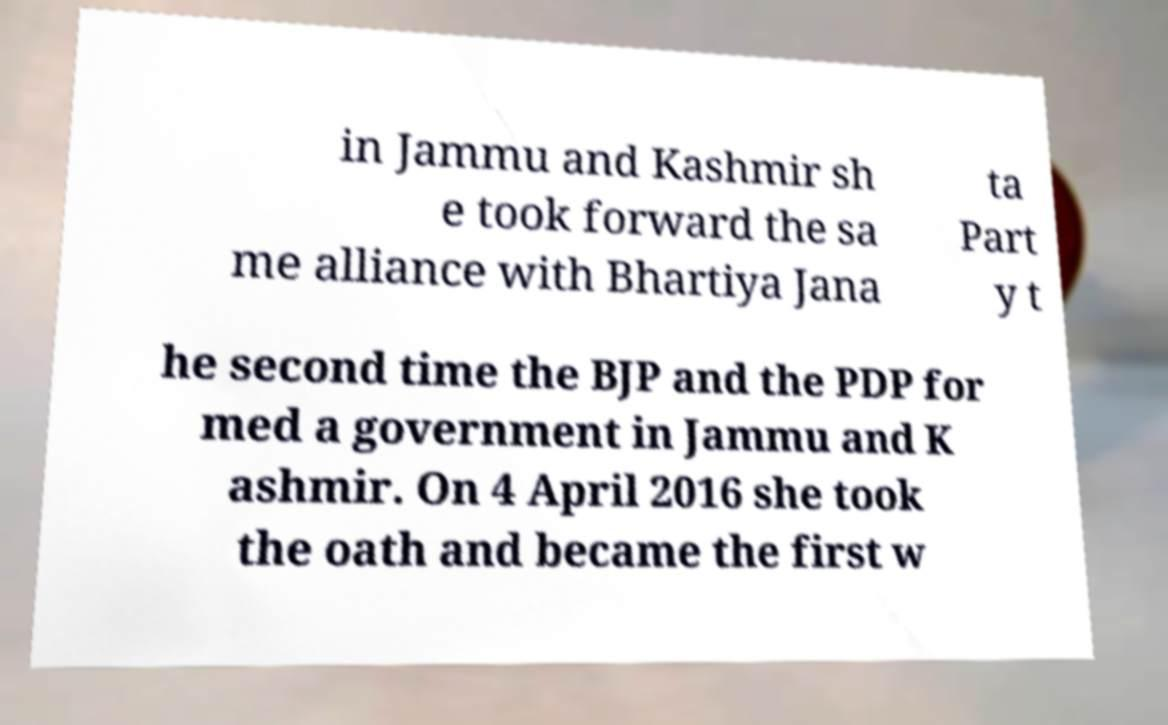Could you assist in decoding the text presented in this image and type it out clearly? in Jammu and Kashmir sh e took forward the sa me alliance with Bhartiya Jana ta Part y t he second time the BJP and the PDP for med a government in Jammu and K ashmir. On 4 April 2016 she took the oath and became the first w 